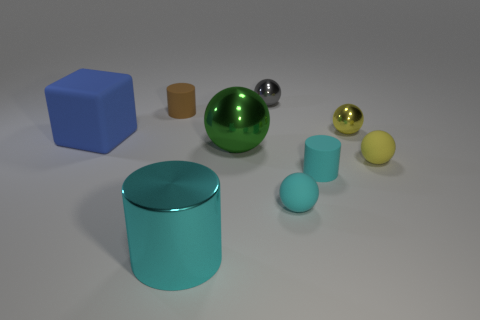Is there a blue matte cube that has the same size as the yellow metallic thing? no 